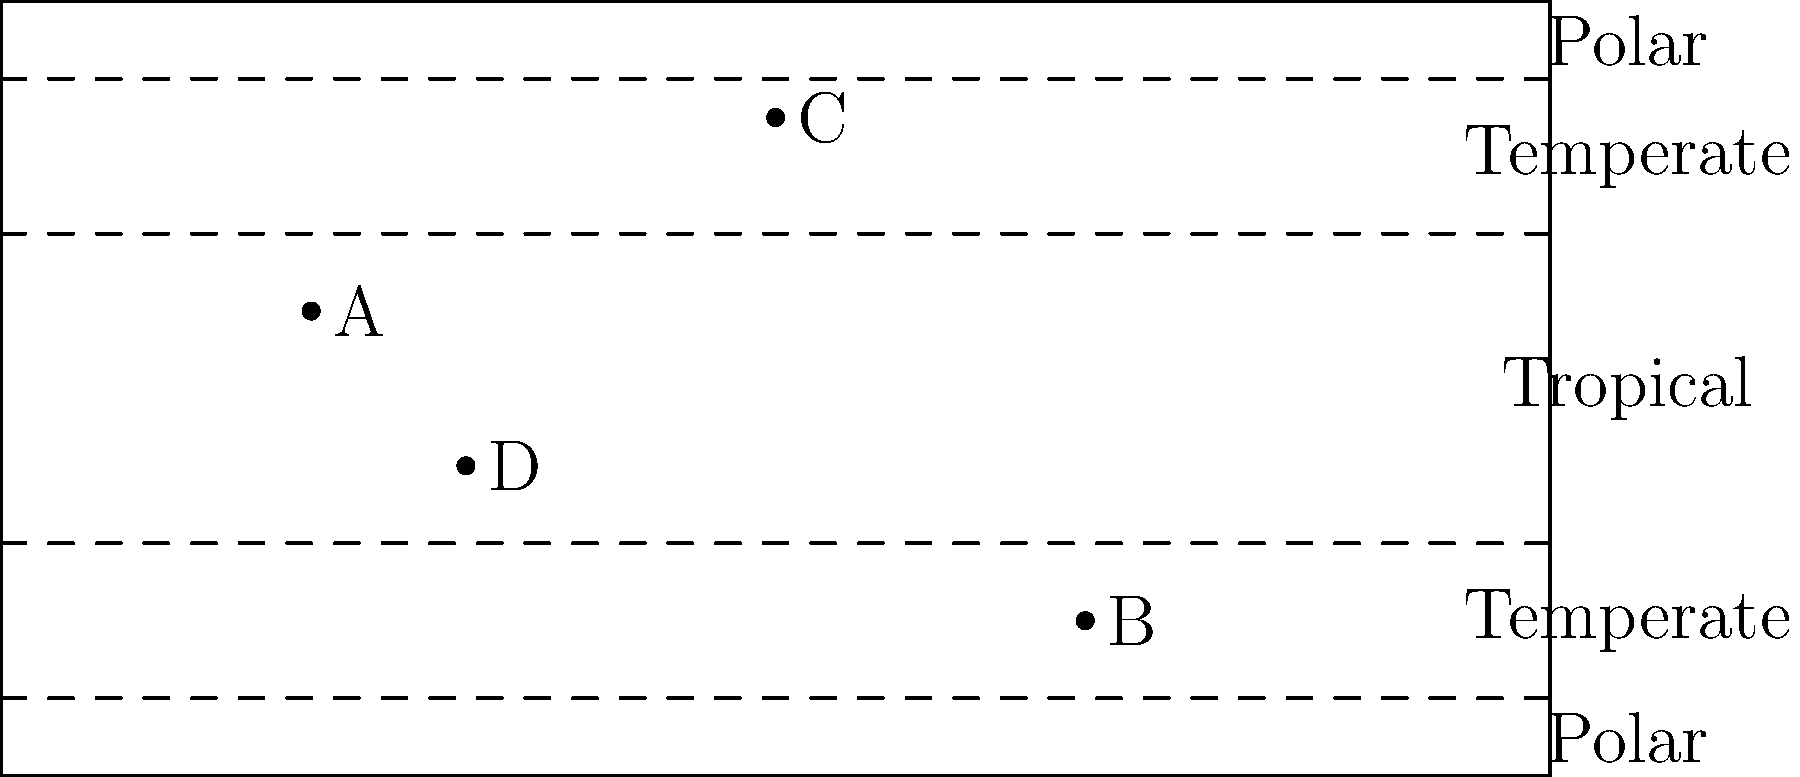Based on the world map showing climate zones, which point represents the most suitable location for cultivating tropical plants that could be used as exotic cocktail ingredients? To answer this question, we need to analyze the climate zones shown on the map and understand the requirements for tropical plant cultivation:

1. The map is divided into five main climate zones: two polar regions, two temperate regions, and one tropical region in the center.

2. Tropical plants typically require warm temperatures year-round and high humidity, which are characteristics of the tropical climate zone.

3. The tropical zone is located between the two dashed lines in the center of the map.

4. Examining the points on the map:
   - Point A is in the northern temperate zone
   - Point B is in the southern temperate zone
   - Point C is in the northern polar zone
   - Point D is in the tropical zone

5. Among these points, only D is located within the tropical climate zone.

6. Tropical plants used for exotic cocktail ingredients, such as passion fruit, coconut, or pineapple, would thrive best in the tropical climate represented by point D.

Therefore, point D represents the most suitable location for cultivating tropical plants that could be used as exotic cocktail ingredients.
Answer: D 